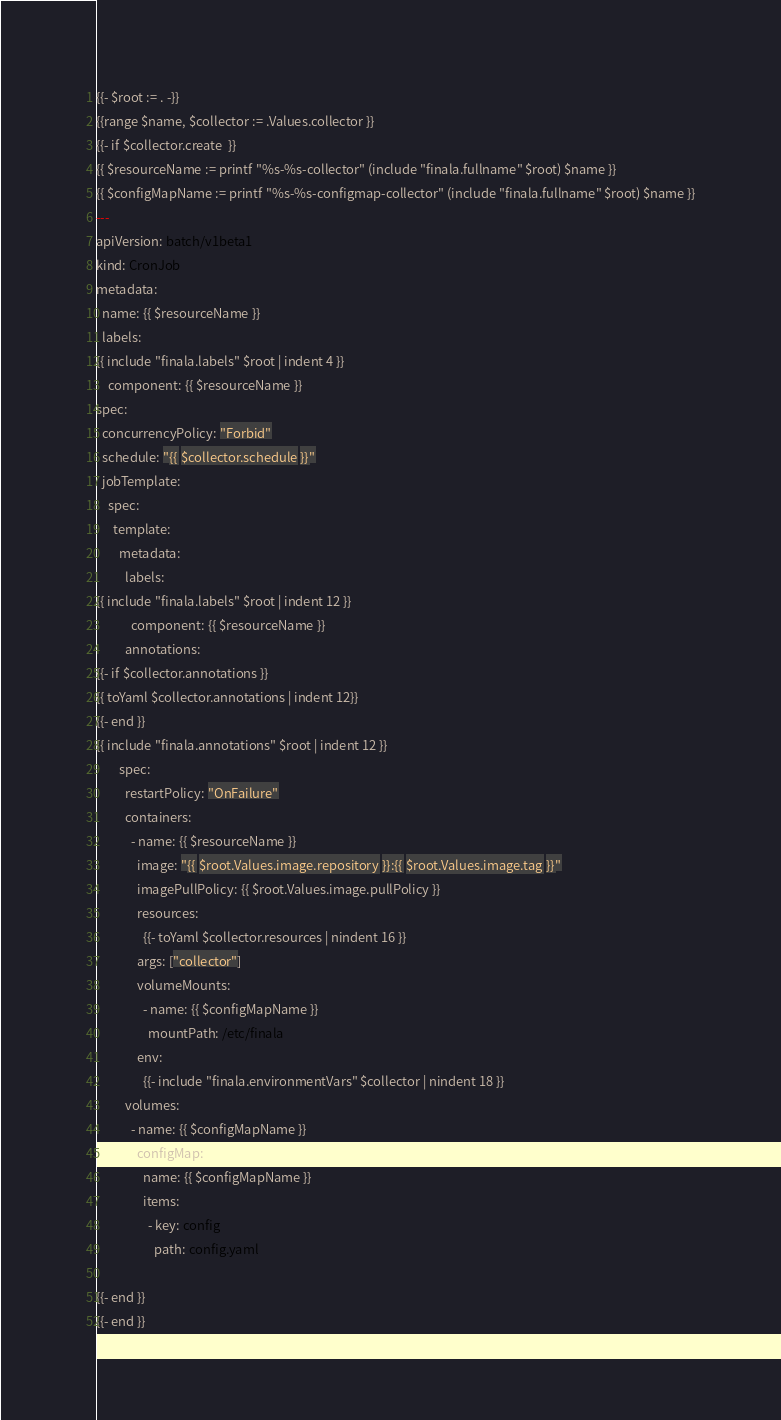Convert code to text. <code><loc_0><loc_0><loc_500><loc_500><_YAML_>{{- $root := . -}}
{{range $name, $collector := .Values.collector }}
{{- if $collector.create  }}
{{ $resourceName := printf "%s-%s-collector" (include "finala.fullname" $root) $name }}
{{ $configMapName := printf "%s-%s-configmap-collector" (include "finala.fullname" $root) $name }}
---
apiVersion: batch/v1beta1
kind: CronJob
metadata:
  name: {{ $resourceName }}
  labels:
{{ include "finala.labels" $root | indent 4 }}
    component: {{ $resourceName }}
spec:
  concurrencyPolicy: "Forbid"
  schedule: "{{ $collector.schedule }}"
  jobTemplate:
    spec:
      template:
        metadata:
          labels:
{{ include "finala.labels" $root | indent 12 }}
            component: {{ $resourceName }}
          annotations:
{{- if $collector.annotations }}
{{ toYaml $collector.annotations | indent 12}}
{{- end }}
{{ include "finala.annotations" $root | indent 12 }}
        spec:
          restartPolicy: "OnFailure"
          containers:
            - name: {{ $resourceName }}
              image: "{{ $root.Values.image.repository }}:{{ $root.Values.image.tag }}"
              imagePullPolicy: {{ $root.Values.image.pullPolicy }}
              resources:
                {{- toYaml $collector.resources | nindent 16 }}
              args: ["collector"]
              volumeMounts:
                - name: {{ $configMapName }}
                  mountPath: /etc/finala
              env:
                {{- include "finala.environmentVars" $collector | nindent 18 }}
          volumes:
            - name: {{ $configMapName }}
              configMap:
                name: {{ $configMapName }}
                items:
                  - key: config
                    path: config.yaml

{{- end }}
{{- end }}</code> 